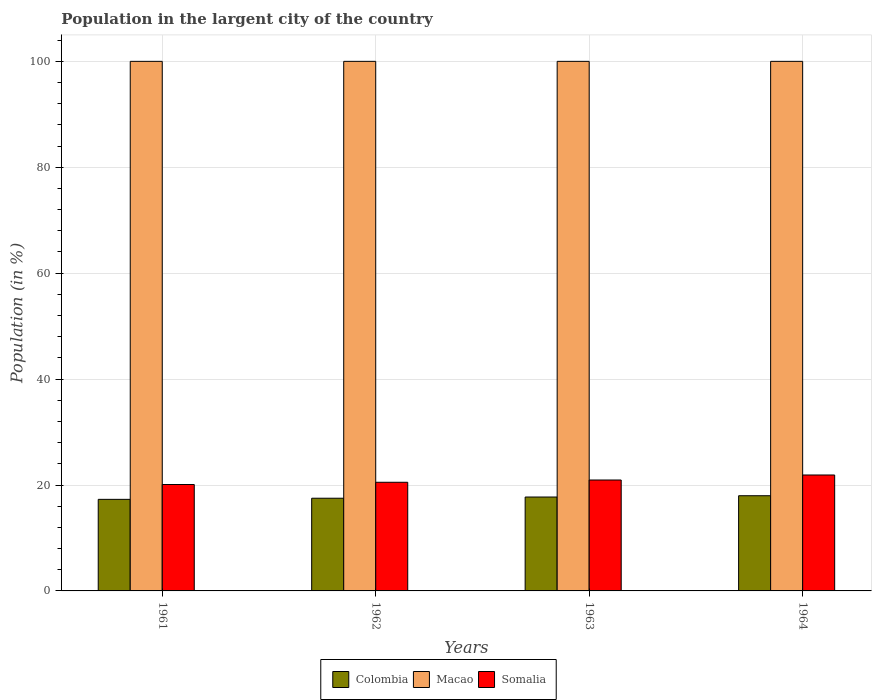How many different coloured bars are there?
Offer a very short reply. 3. What is the percentage of population in the largent city in Macao in 1964?
Make the answer very short. 100. Across all years, what is the maximum percentage of population in the largent city in Macao?
Offer a very short reply. 100. Across all years, what is the minimum percentage of population in the largent city in Macao?
Provide a succinct answer. 100. In which year was the percentage of population in the largent city in Somalia maximum?
Provide a short and direct response. 1964. What is the difference between the percentage of population in the largent city in Colombia in 1963 and that in 1964?
Provide a succinct answer. -0.24. What is the difference between the percentage of population in the largent city in Macao in 1962 and the percentage of population in the largent city in Somalia in 1963?
Your response must be concise. 79.06. In the year 1962, what is the difference between the percentage of population in the largent city in Macao and percentage of population in the largent city in Somalia?
Keep it short and to the point. 79.48. In how many years, is the percentage of population in the largent city in Colombia greater than 8 %?
Provide a succinct answer. 4. Is the difference between the percentage of population in the largent city in Macao in 1963 and 1964 greater than the difference between the percentage of population in the largent city in Somalia in 1963 and 1964?
Ensure brevity in your answer.  Yes. What is the difference between the highest and the lowest percentage of population in the largent city in Somalia?
Give a very brief answer. 1.8. What does the 1st bar from the right in 1964 represents?
Give a very brief answer. Somalia. Is it the case that in every year, the sum of the percentage of population in the largent city in Somalia and percentage of population in the largent city in Colombia is greater than the percentage of population in the largent city in Macao?
Give a very brief answer. No. How many years are there in the graph?
Your answer should be compact. 4. Does the graph contain any zero values?
Make the answer very short. No. Does the graph contain grids?
Provide a succinct answer. Yes. How are the legend labels stacked?
Ensure brevity in your answer.  Horizontal. What is the title of the graph?
Make the answer very short. Population in the largent city of the country. Does "United Kingdom" appear as one of the legend labels in the graph?
Give a very brief answer. No. What is the Population (in %) of Colombia in 1961?
Offer a terse response. 17.29. What is the Population (in %) of Somalia in 1961?
Offer a very short reply. 20.1. What is the Population (in %) of Colombia in 1962?
Your answer should be very brief. 17.5. What is the Population (in %) in Somalia in 1962?
Keep it short and to the point. 20.52. What is the Population (in %) in Colombia in 1963?
Ensure brevity in your answer.  17.73. What is the Population (in %) of Somalia in 1963?
Provide a succinct answer. 20.94. What is the Population (in %) of Colombia in 1964?
Keep it short and to the point. 17.98. What is the Population (in %) of Somalia in 1964?
Make the answer very short. 21.89. Across all years, what is the maximum Population (in %) of Colombia?
Your response must be concise. 17.98. Across all years, what is the maximum Population (in %) in Macao?
Provide a short and direct response. 100. Across all years, what is the maximum Population (in %) in Somalia?
Your answer should be very brief. 21.89. Across all years, what is the minimum Population (in %) of Colombia?
Your response must be concise. 17.29. Across all years, what is the minimum Population (in %) in Macao?
Offer a very short reply. 100. Across all years, what is the minimum Population (in %) in Somalia?
Offer a terse response. 20.1. What is the total Population (in %) of Colombia in the graph?
Keep it short and to the point. 70.5. What is the total Population (in %) of Macao in the graph?
Make the answer very short. 400. What is the total Population (in %) in Somalia in the graph?
Keep it short and to the point. 83.45. What is the difference between the Population (in %) in Colombia in 1961 and that in 1962?
Offer a very short reply. -0.21. What is the difference between the Population (in %) of Somalia in 1961 and that in 1962?
Keep it short and to the point. -0.42. What is the difference between the Population (in %) in Colombia in 1961 and that in 1963?
Your answer should be compact. -0.44. What is the difference between the Population (in %) of Macao in 1961 and that in 1963?
Keep it short and to the point. 0. What is the difference between the Population (in %) in Somalia in 1961 and that in 1963?
Provide a short and direct response. -0.85. What is the difference between the Population (in %) of Colombia in 1961 and that in 1964?
Your answer should be compact. -0.68. What is the difference between the Population (in %) of Macao in 1961 and that in 1964?
Your response must be concise. 0. What is the difference between the Population (in %) in Somalia in 1961 and that in 1964?
Keep it short and to the point. -1.8. What is the difference between the Population (in %) in Colombia in 1962 and that in 1963?
Ensure brevity in your answer.  -0.23. What is the difference between the Population (in %) in Macao in 1962 and that in 1963?
Your response must be concise. 0. What is the difference between the Population (in %) in Somalia in 1962 and that in 1963?
Make the answer very short. -0.43. What is the difference between the Population (in %) of Colombia in 1962 and that in 1964?
Ensure brevity in your answer.  -0.47. What is the difference between the Population (in %) of Macao in 1962 and that in 1964?
Give a very brief answer. 0. What is the difference between the Population (in %) of Somalia in 1962 and that in 1964?
Your answer should be very brief. -1.38. What is the difference between the Population (in %) of Colombia in 1963 and that in 1964?
Provide a short and direct response. -0.24. What is the difference between the Population (in %) in Macao in 1963 and that in 1964?
Your answer should be compact. 0. What is the difference between the Population (in %) of Somalia in 1963 and that in 1964?
Your response must be concise. -0.95. What is the difference between the Population (in %) in Colombia in 1961 and the Population (in %) in Macao in 1962?
Offer a terse response. -82.71. What is the difference between the Population (in %) in Colombia in 1961 and the Population (in %) in Somalia in 1962?
Offer a very short reply. -3.22. What is the difference between the Population (in %) of Macao in 1961 and the Population (in %) of Somalia in 1962?
Offer a very short reply. 79.48. What is the difference between the Population (in %) of Colombia in 1961 and the Population (in %) of Macao in 1963?
Provide a succinct answer. -82.71. What is the difference between the Population (in %) of Colombia in 1961 and the Population (in %) of Somalia in 1963?
Your response must be concise. -3.65. What is the difference between the Population (in %) of Macao in 1961 and the Population (in %) of Somalia in 1963?
Provide a succinct answer. 79.06. What is the difference between the Population (in %) in Colombia in 1961 and the Population (in %) in Macao in 1964?
Make the answer very short. -82.71. What is the difference between the Population (in %) in Colombia in 1961 and the Population (in %) in Somalia in 1964?
Your response must be concise. -4.6. What is the difference between the Population (in %) of Macao in 1961 and the Population (in %) of Somalia in 1964?
Your answer should be very brief. 78.11. What is the difference between the Population (in %) in Colombia in 1962 and the Population (in %) in Macao in 1963?
Offer a very short reply. -82.5. What is the difference between the Population (in %) of Colombia in 1962 and the Population (in %) of Somalia in 1963?
Make the answer very short. -3.44. What is the difference between the Population (in %) in Macao in 1962 and the Population (in %) in Somalia in 1963?
Ensure brevity in your answer.  79.06. What is the difference between the Population (in %) in Colombia in 1962 and the Population (in %) in Macao in 1964?
Make the answer very short. -82.5. What is the difference between the Population (in %) in Colombia in 1962 and the Population (in %) in Somalia in 1964?
Offer a very short reply. -4.39. What is the difference between the Population (in %) in Macao in 1962 and the Population (in %) in Somalia in 1964?
Ensure brevity in your answer.  78.11. What is the difference between the Population (in %) of Colombia in 1963 and the Population (in %) of Macao in 1964?
Your answer should be very brief. -82.27. What is the difference between the Population (in %) of Colombia in 1963 and the Population (in %) of Somalia in 1964?
Your answer should be very brief. -4.16. What is the difference between the Population (in %) in Macao in 1963 and the Population (in %) in Somalia in 1964?
Your response must be concise. 78.11. What is the average Population (in %) of Colombia per year?
Provide a short and direct response. 17.63. What is the average Population (in %) in Somalia per year?
Offer a very short reply. 20.86. In the year 1961, what is the difference between the Population (in %) of Colombia and Population (in %) of Macao?
Provide a short and direct response. -82.71. In the year 1961, what is the difference between the Population (in %) of Colombia and Population (in %) of Somalia?
Offer a terse response. -2.8. In the year 1961, what is the difference between the Population (in %) in Macao and Population (in %) in Somalia?
Give a very brief answer. 79.9. In the year 1962, what is the difference between the Population (in %) in Colombia and Population (in %) in Macao?
Give a very brief answer. -82.5. In the year 1962, what is the difference between the Population (in %) in Colombia and Population (in %) in Somalia?
Provide a short and direct response. -3.01. In the year 1962, what is the difference between the Population (in %) of Macao and Population (in %) of Somalia?
Give a very brief answer. 79.48. In the year 1963, what is the difference between the Population (in %) of Colombia and Population (in %) of Macao?
Offer a very short reply. -82.27. In the year 1963, what is the difference between the Population (in %) in Colombia and Population (in %) in Somalia?
Provide a succinct answer. -3.21. In the year 1963, what is the difference between the Population (in %) in Macao and Population (in %) in Somalia?
Your answer should be very brief. 79.06. In the year 1964, what is the difference between the Population (in %) in Colombia and Population (in %) in Macao?
Offer a terse response. -82.02. In the year 1964, what is the difference between the Population (in %) of Colombia and Population (in %) of Somalia?
Keep it short and to the point. -3.92. In the year 1964, what is the difference between the Population (in %) of Macao and Population (in %) of Somalia?
Your answer should be compact. 78.11. What is the ratio of the Population (in %) in Colombia in 1961 to that in 1962?
Offer a terse response. 0.99. What is the ratio of the Population (in %) in Somalia in 1961 to that in 1962?
Make the answer very short. 0.98. What is the ratio of the Population (in %) in Colombia in 1961 to that in 1963?
Ensure brevity in your answer.  0.98. What is the ratio of the Population (in %) of Somalia in 1961 to that in 1963?
Provide a succinct answer. 0.96. What is the ratio of the Population (in %) in Colombia in 1961 to that in 1964?
Keep it short and to the point. 0.96. What is the ratio of the Population (in %) of Somalia in 1961 to that in 1964?
Provide a succinct answer. 0.92. What is the ratio of the Population (in %) of Colombia in 1962 to that in 1963?
Your answer should be compact. 0.99. What is the ratio of the Population (in %) of Macao in 1962 to that in 1963?
Offer a terse response. 1. What is the ratio of the Population (in %) in Somalia in 1962 to that in 1963?
Your answer should be compact. 0.98. What is the ratio of the Population (in %) of Colombia in 1962 to that in 1964?
Make the answer very short. 0.97. What is the ratio of the Population (in %) of Macao in 1962 to that in 1964?
Keep it short and to the point. 1. What is the ratio of the Population (in %) in Somalia in 1962 to that in 1964?
Ensure brevity in your answer.  0.94. What is the ratio of the Population (in %) in Colombia in 1963 to that in 1964?
Ensure brevity in your answer.  0.99. What is the ratio of the Population (in %) in Macao in 1963 to that in 1964?
Your answer should be compact. 1. What is the ratio of the Population (in %) of Somalia in 1963 to that in 1964?
Your answer should be very brief. 0.96. What is the difference between the highest and the second highest Population (in %) in Colombia?
Provide a succinct answer. 0.24. What is the difference between the highest and the second highest Population (in %) of Somalia?
Your answer should be very brief. 0.95. What is the difference between the highest and the lowest Population (in %) in Colombia?
Ensure brevity in your answer.  0.68. What is the difference between the highest and the lowest Population (in %) in Somalia?
Offer a terse response. 1.8. 